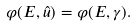Convert formula to latex. <formula><loc_0><loc_0><loc_500><loc_500>\varphi ( E , { \hat { u } } ) = \varphi ( E , \gamma ) .</formula> 